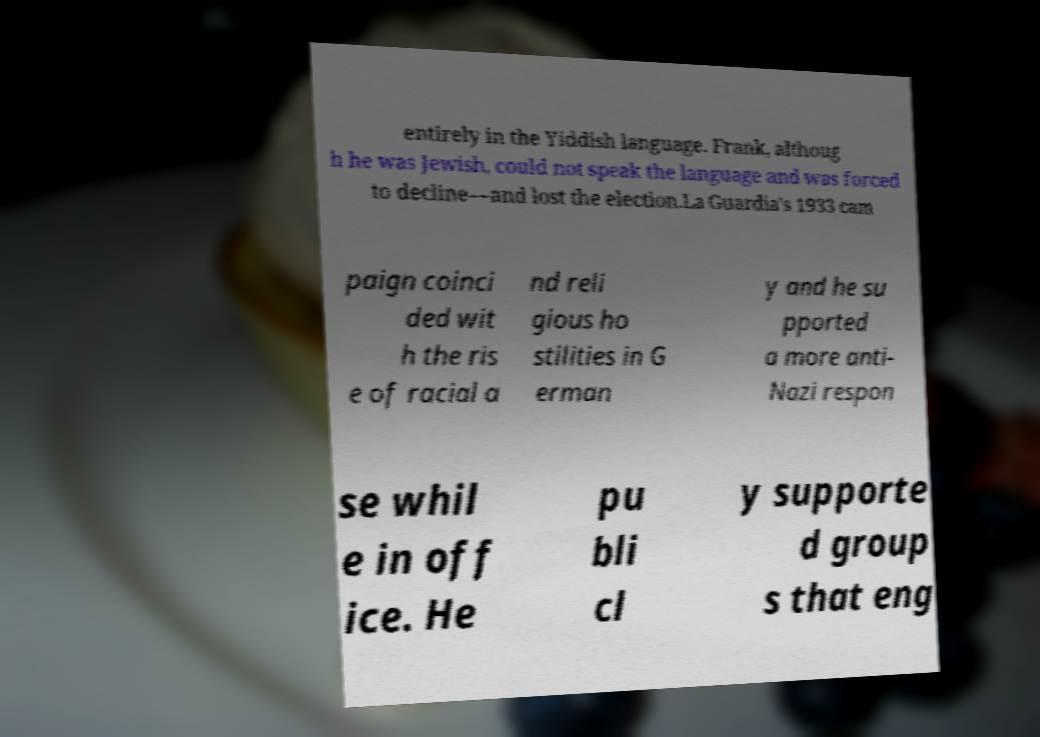I need the written content from this picture converted into text. Can you do that? entirely in the Yiddish language. Frank, althoug h he was Jewish, could not speak the language and was forced to decline—and lost the election.La Guardia's 1933 cam paign coinci ded wit h the ris e of racial a nd reli gious ho stilities in G erman y and he su pported a more anti- Nazi respon se whil e in off ice. He pu bli cl y supporte d group s that eng 